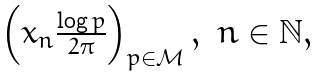<formula> <loc_0><loc_0><loc_500><loc_500>\begin{array} { c c } \left ( x _ { n } \frac { \log p } { 2 \pi } \right ) _ { p \in \mathcal { M } } , & n \in \mathbb { N } , \end{array}</formula> 